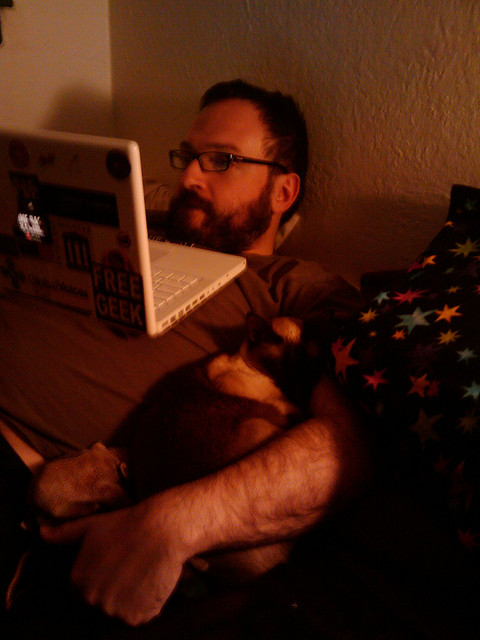Read all the text in this image. FREE GEEK 